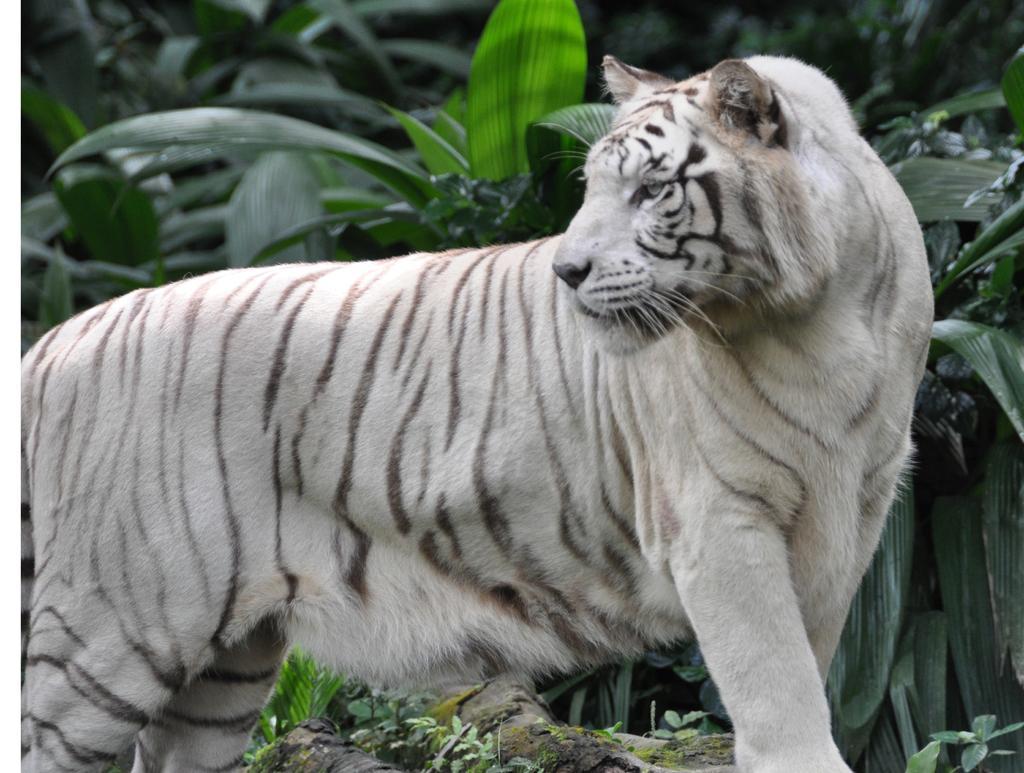Could you give a brief overview of what you see in this image? In this picture there is a tiger standing. At the back there are plants. At the bottom there might be a tree branch. 